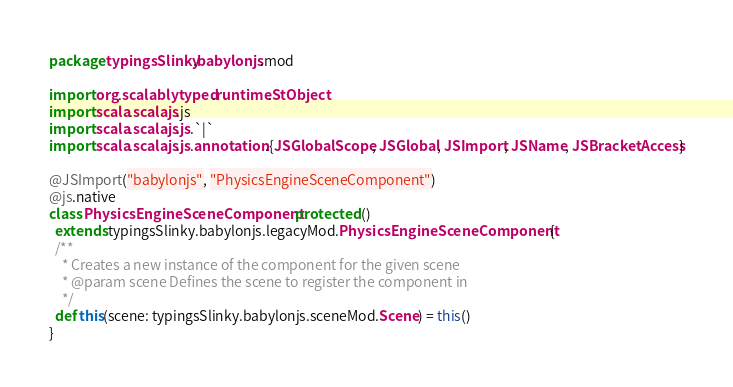<code> <loc_0><loc_0><loc_500><loc_500><_Scala_>package typingsSlinky.babylonjs.mod

import org.scalablytyped.runtime.StObject
import scala.scalajs.js
import scala.scalajs.js.`|`
import scala.scalajs.js.annotation.{JSGlobalScope, JSGlobal, JSImport, JSName, JSBracketAccess}

@JSImport("babylonjs", "PhysicsEngineSceneComponent")
@js.native
class PhysicsEngineSceneComponent protected ()
  extends typingsSlinky.babylonjs.legacyMod.PhysicsEngineSceneComponent {
  /**
    * Creates a new instance of the component for the given scene
    * @param scene Defines the scene to register the component in
    */
  def this(scene: typingsSlinky.babylonjs.sceneMod.Scene) = this()
}
</code> 